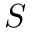<formula> <loc_0><loc_0><loc_500><loc_500>S</formula> 